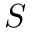<formula> <loc_0><loc_0><loc_500><loc_500>S</formula> 